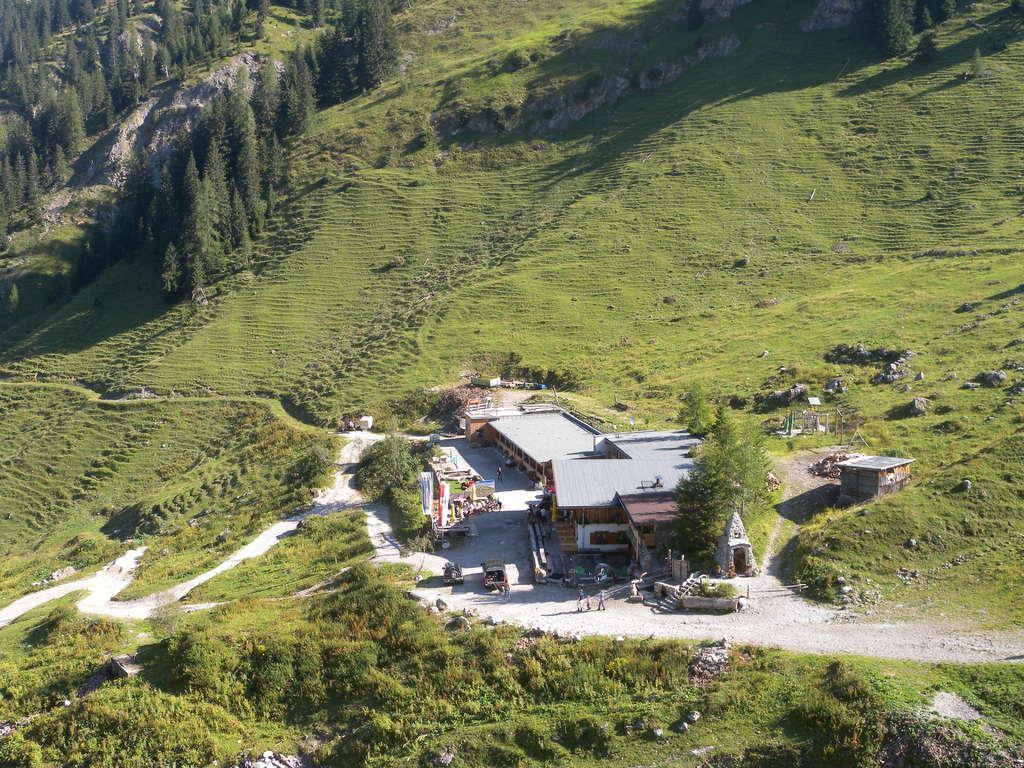Could you give a brief overview of what you see in this image? In this picture we can observe houses here. There are some trees. We can observe some grass on the land in this picture. 